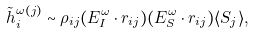<formula> <loc_0><loc_0><loc_500><loc_500>\tilde { h } _ { i } ^ { \omega ( j ) } \sim \rho _ { i j } ( { E } _ { I } ^ { \omega } \cdot { r } _ { i j } ) ( { E } _ { S } ^ { \omega } \cdot { r } _ { i j } ) \langle { S } _ { j } \rangle ,</formula> 